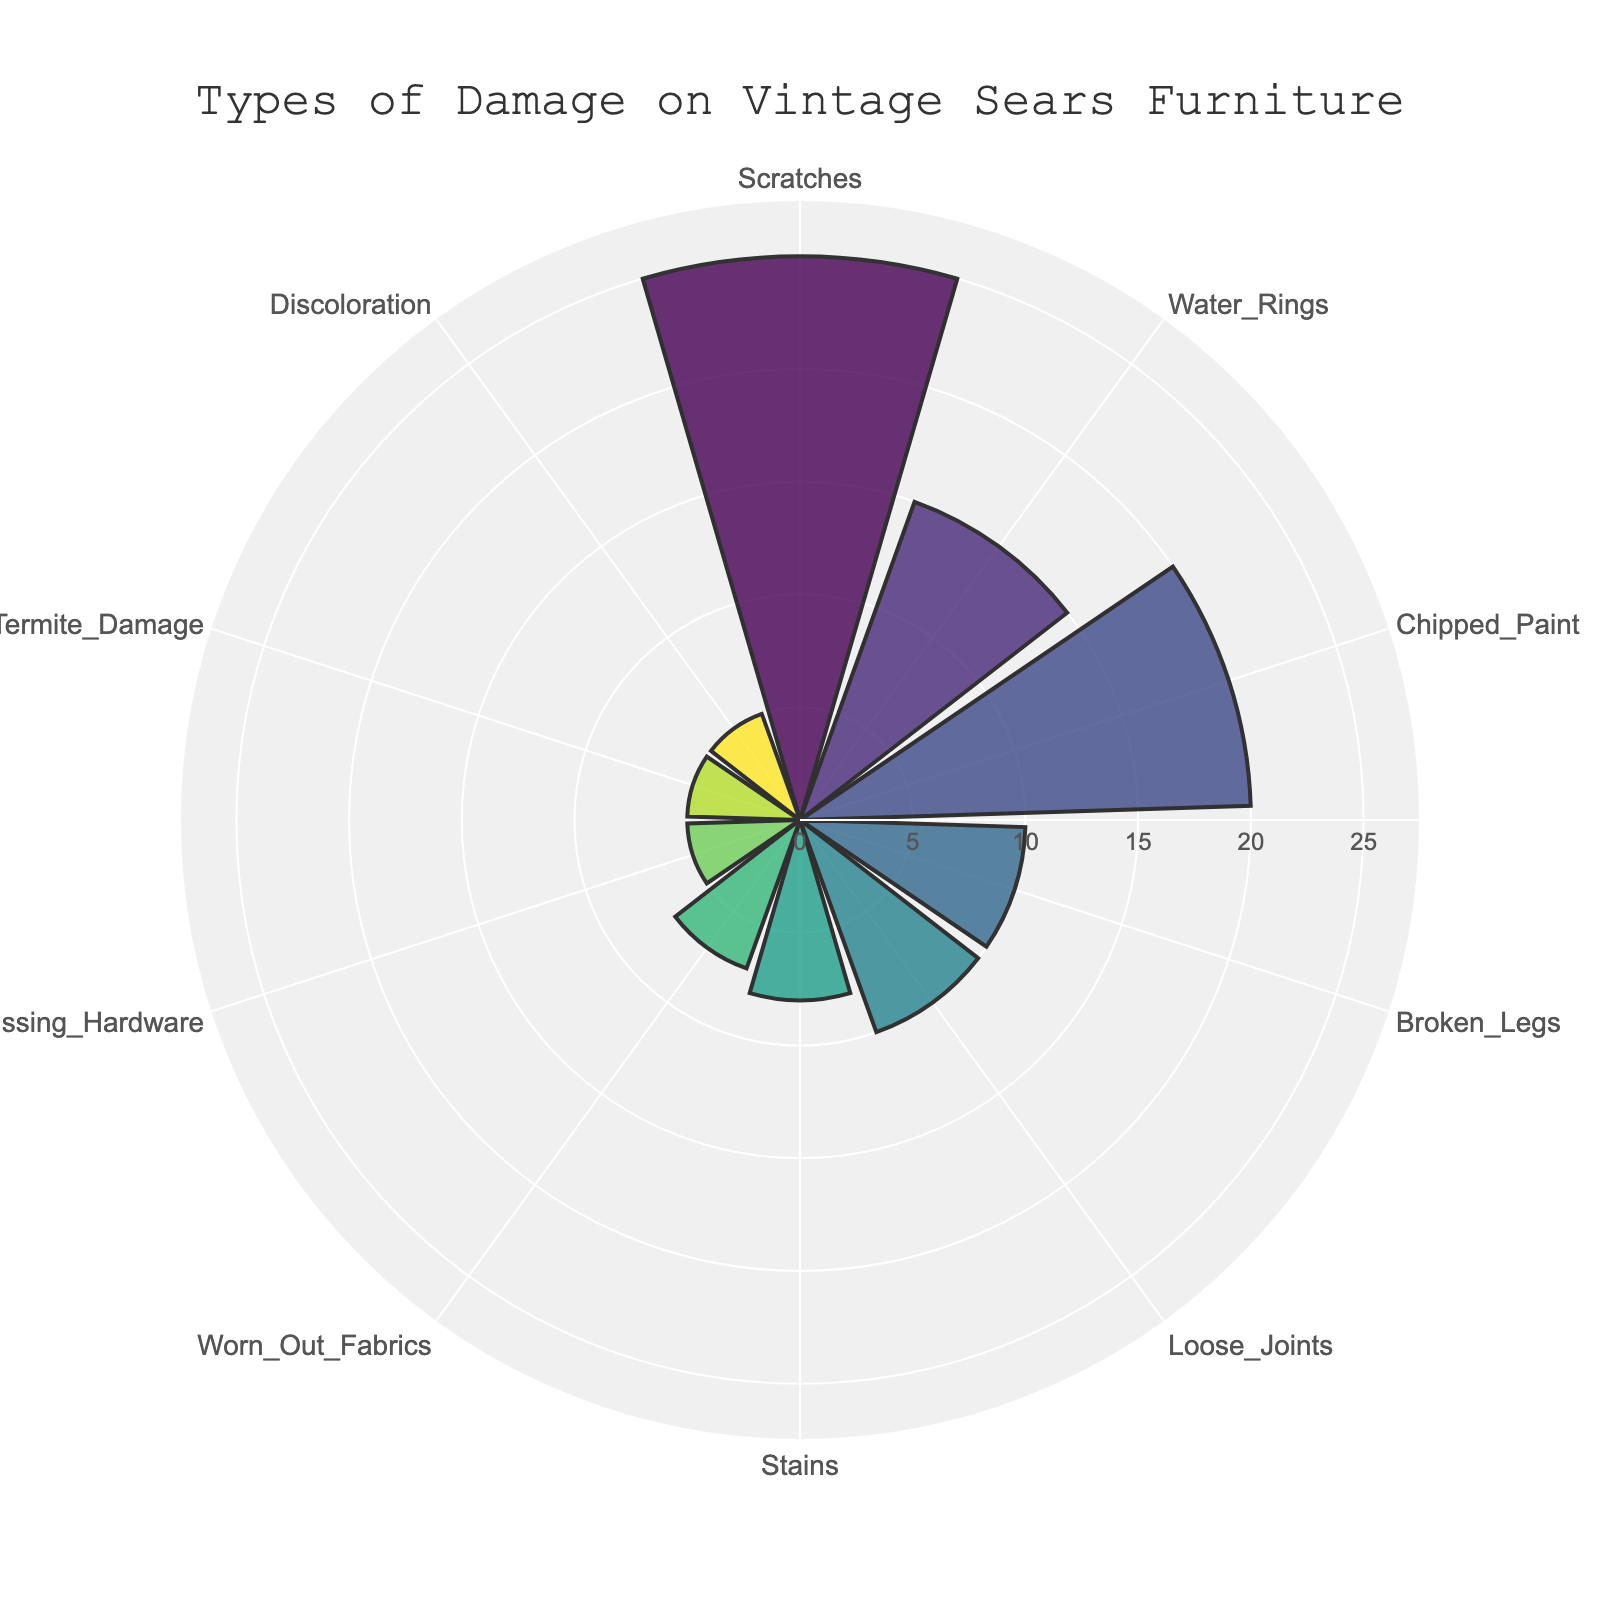What is the title of the figure? The title of the figure is usually displayed at the top. In this case, it's "Types of Damage on Vintage Sears Furniture".
Answer: Types of Damage on Vintage Sears Furniture Which type of damage has the highest proportion? To find the type of damage with the highest proportion, look for the longest bar in the rose chart. The longest bar corresponds to scratches with a proportion of 25.
Answer: Scratches How many types of damage have a proportion of 10? Count the bars that correspond to a proportion of 10. There are two categories: "Broken Legs" and "Loose Joints".
Answer: 2 What is the combined proportion of "Water Rings" and "Stains"? Identify the proportions for Water Rings (15) and Stains (8). Add them together (15 + 8).
Answer: 23 Is the proportion of "Termite Damage" equal to "Discoloration"? Compare the proportions of Termite Damage and Discoloration. Both have a value of 5.
Answer: Yes Which type of damage has the smallest proportion? To identify the smallest proportion, look for the shortest bar in the rose chart. The shortest bars correspond to "Missing Hardware," "Termite Damage," and "Discoloration," all with a proportion of 5.
Answer: Missing Hardware/Termite Damage/Discoloration How does the proportion of "Chipped Paint" compare to "Broken Legs"? Compare the lengths of the bars for Chipped Paint (20) and Broken Legs (10). Chipped Paint has a higher proportion.
Answer: Chipped Paint is greater What is the average proportion of the listed types of damage? To find the average, sum all the proportions (25 + 15 + 20 + 10 + 10 + 8 + 7 + 5 + 5 + 5 = 110) and divide by the number of types (10).
Answer: 11 Which three types of damage have proportions greater than or equal to 20? Identify the bars that meet or exceed 20 in length. These are "Scratches" (25) and "Chipped Paint" (20).
Answer: Scratches, Chipped Paint What is the total proportion of all types of damage combined? Sum all the individual proportions: 25 + 15 + 20 + 10 + 10 + 8 + 7 + 5 + 5 + 5 = 110.
Answer: 110 